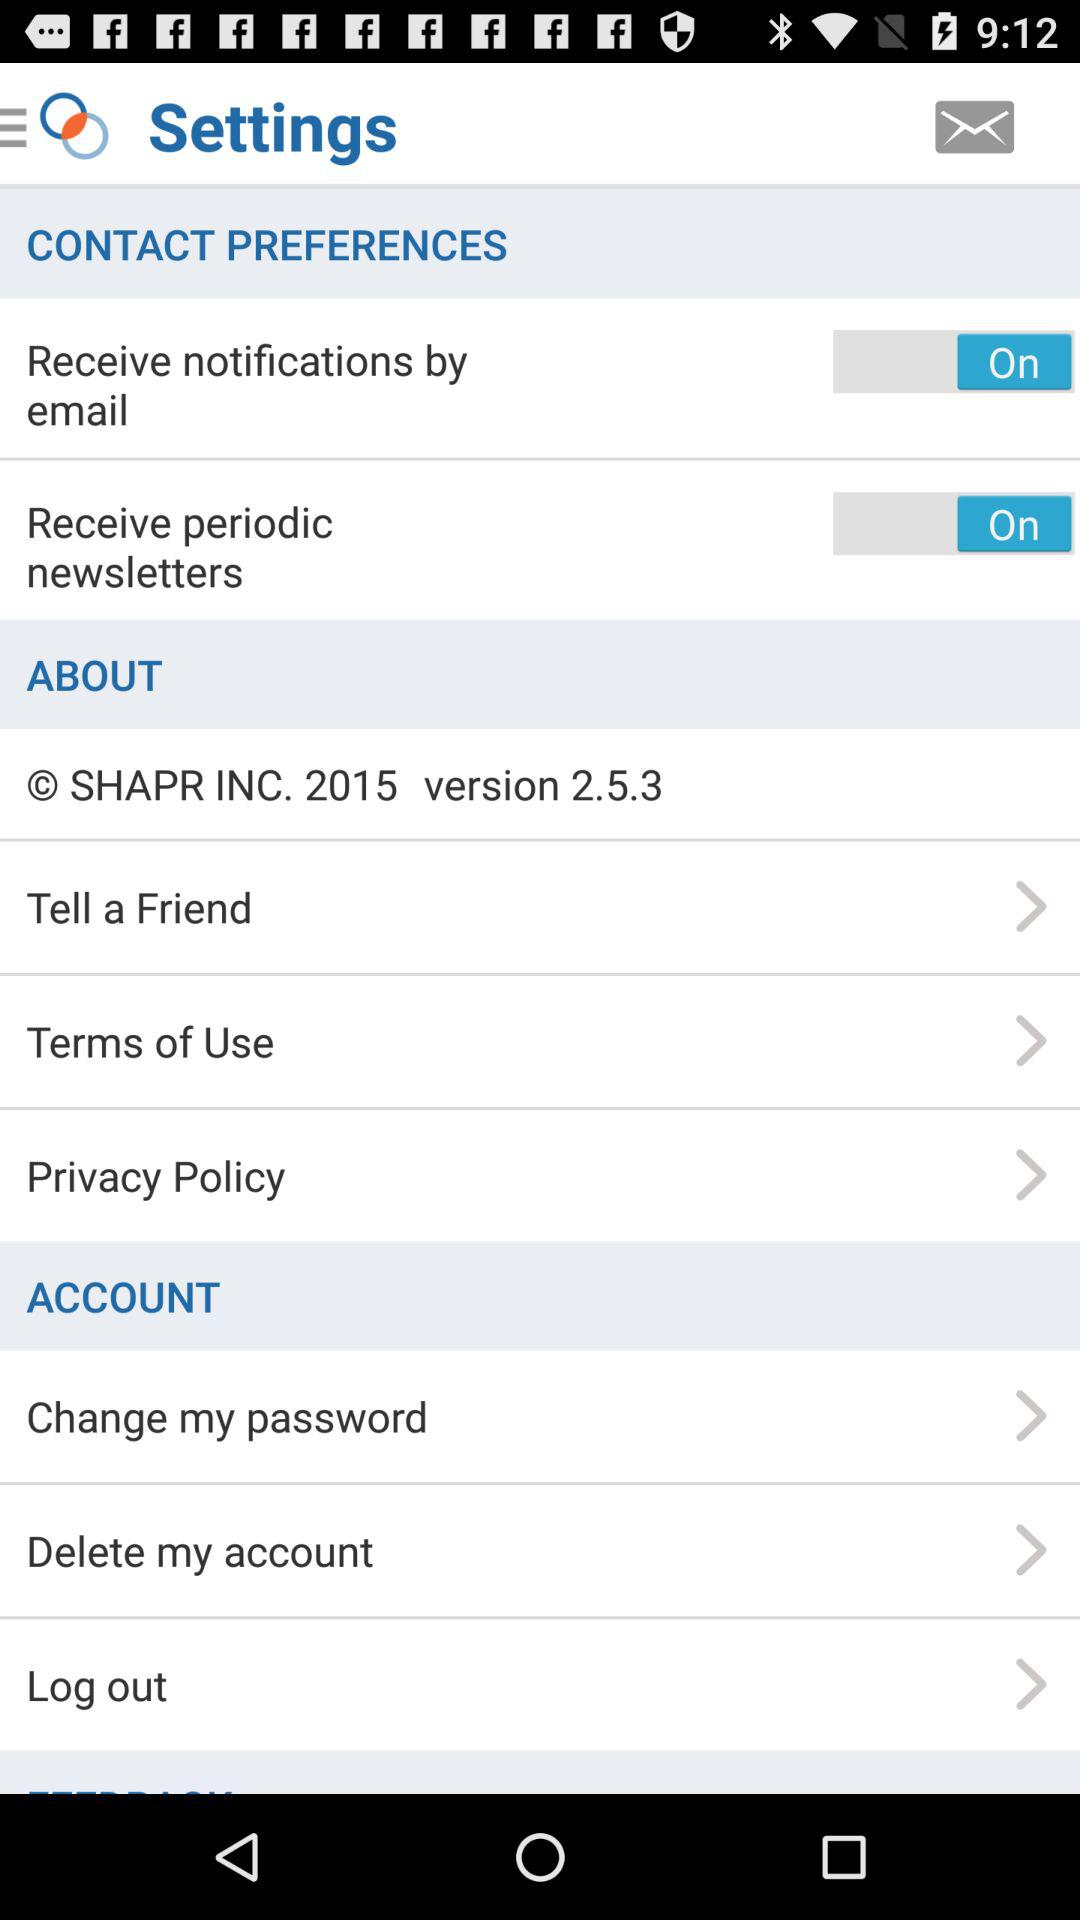What is the version? The version is 2.5.3. 